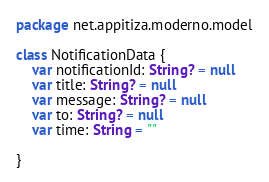<code> <loc_0><loc_0><loc_500><loc_500><_Kotlin_>package net.appitiza.moderno.model

class NotificationData {
    var notificationId: String? = null
    var title: String? = null
    var message: String? = null
    var to: String? = null
    var time: String = ""

}</code> 